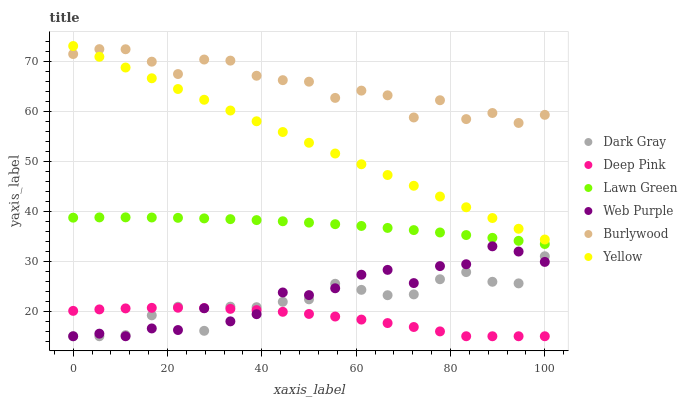Does Deep Pink have the minimum area under the curve?
Answer yes or no. Yes. Does Burlywood have the maximum area under the curve?
Answer yes or no. Yes. Does Burlywood have the minimum area under the curve?
Answer yes or no. No. Does Deep Pink have the maximum area under the curve?
Answer yes or no. No. Is Yellow the smoothest?
Answer yes or no. Yes. Is Burlywood the roughest?
Answer yes or no. Yes. Is Deep Pink the smoothest?
Answer yes or no. No. Is Deep Pink the roughest?
Answer yes or no. No. Does Deep Pink have the lowest value?
Answer yes or no. Yes. Does Burlywood have the lowest value?
Answer yes or no. No. Does Yellow have the highest value?
Answer yes or no. Yes. Does Burlywood have the highest value?
Answer yes or no. No. Is Deep Pink less than Burlywood?
Answer yes or no. Yes. Is Yellow greater than Dark Gray?
Answer yes or no. Yes. Does Deep Pink intersect Web Purple?
Answer yes or no. Yes. Is Deep Pink less than Web Purple?
Answer yes or no. No. Is Deep Pink greater than Web Purple?
Answer yes or no. No. Does Deep Pink intersect Burlywood?
Answer yes or no. No. 